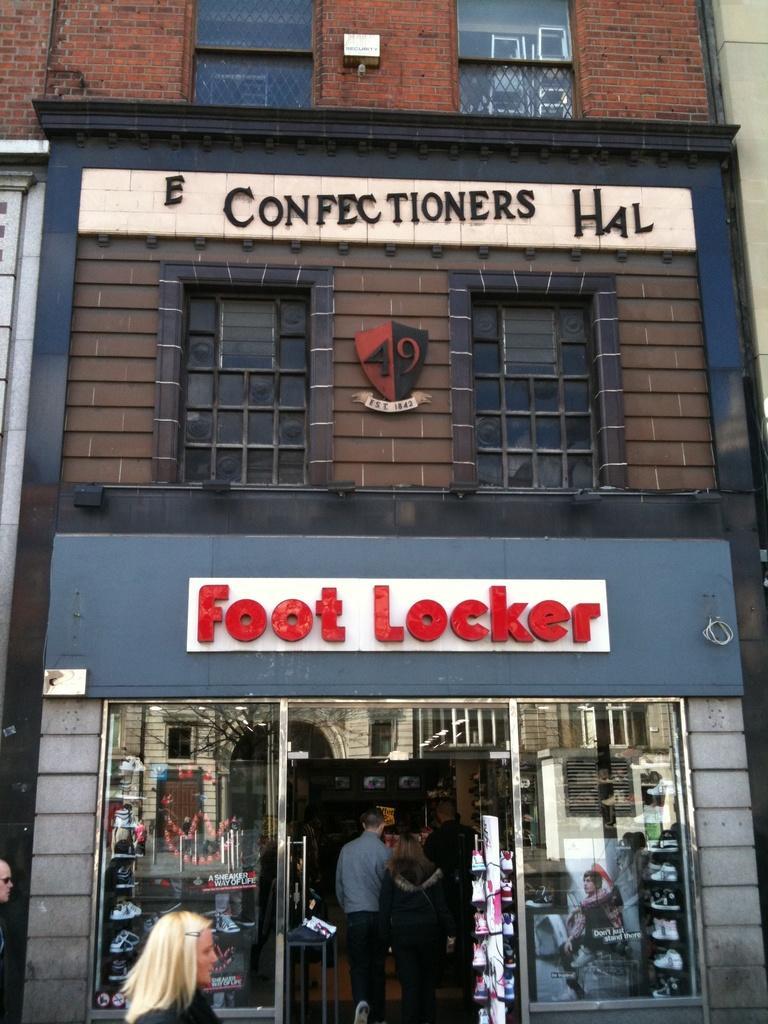In one or two sentences, can you explain what this image depicts? In the center of the image we can see building. At the bottom of the image we can see persons and store. 